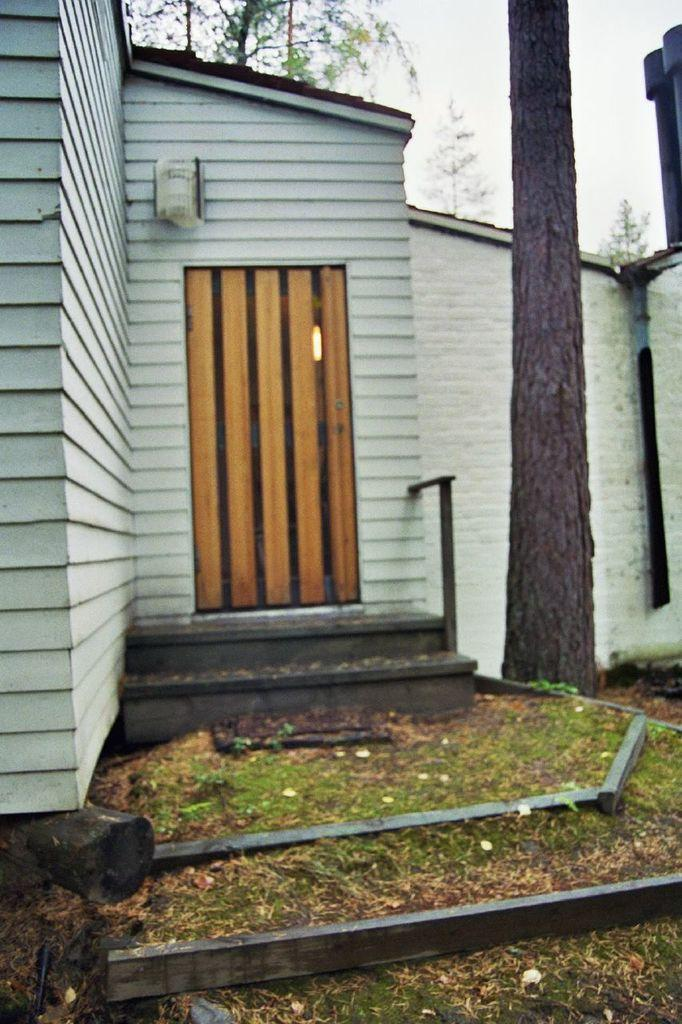What type of structure is present in the image? There is a building in the image. What feature of the building is mentioned in the facts? The building has a door and a light. What is located in front of the building? There are stairs and a tree in front of the building. What can be seen in the background of the image? The sky is visible in the background of the image. What type of experience does the judge have with the building in the image? There is no judge present in the image, and therefore no experience to discuss. 